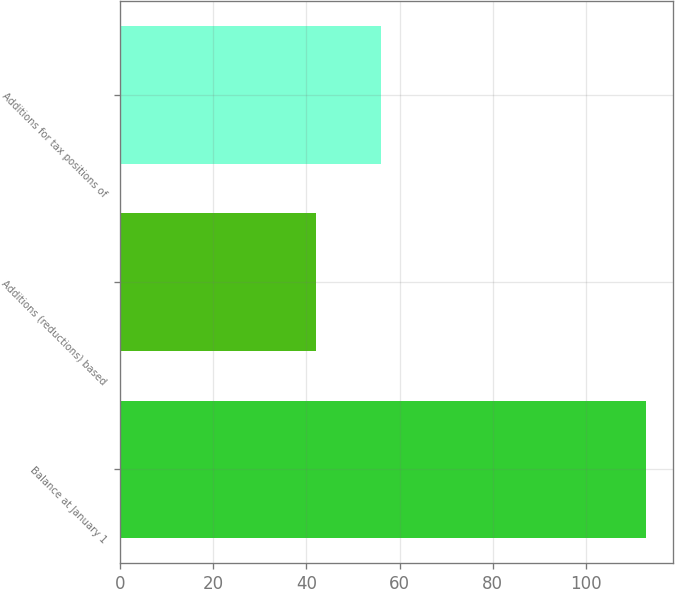Convert chart. <chart><loc_0><loc_0><loc_500><loc_500><bar_chart><fcel>Balance at January 1<fcel>Additions (reductions) based<fcel>Additions for tax positions of<nl><fcel>113<fcel>42<fcel>56<nl></chart> 